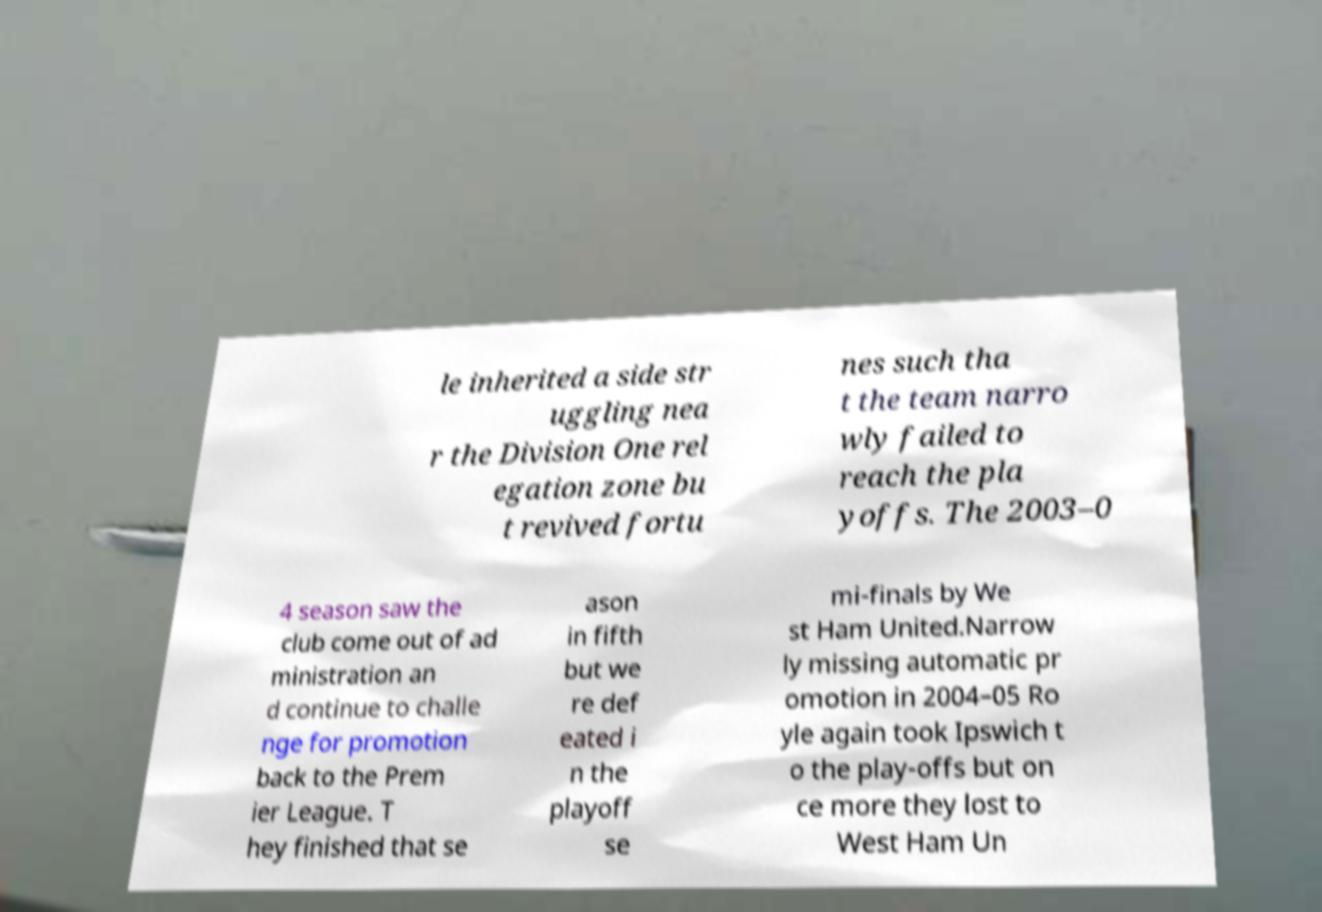Please read and relay the text visible in this image. What does it say? le inherited a side str uggling nea r the Division One rel egation zone bu t revived fortu nes such tha t the team narro wly failed to reach the pla yoffs. The 2003–0 4 season saw the club come out of ad ministration an d continue to challe nge for promotion back to the Prem ier League. T hey finished that se ason in fifth but we re def eated i n the playoff se mi-finals by We st Ham United.Narrow ly missing automatic pr omotion in 2004–05 Ro yle again took Ipswich t o the play-offs but on ce more they lost to West Ham Un 